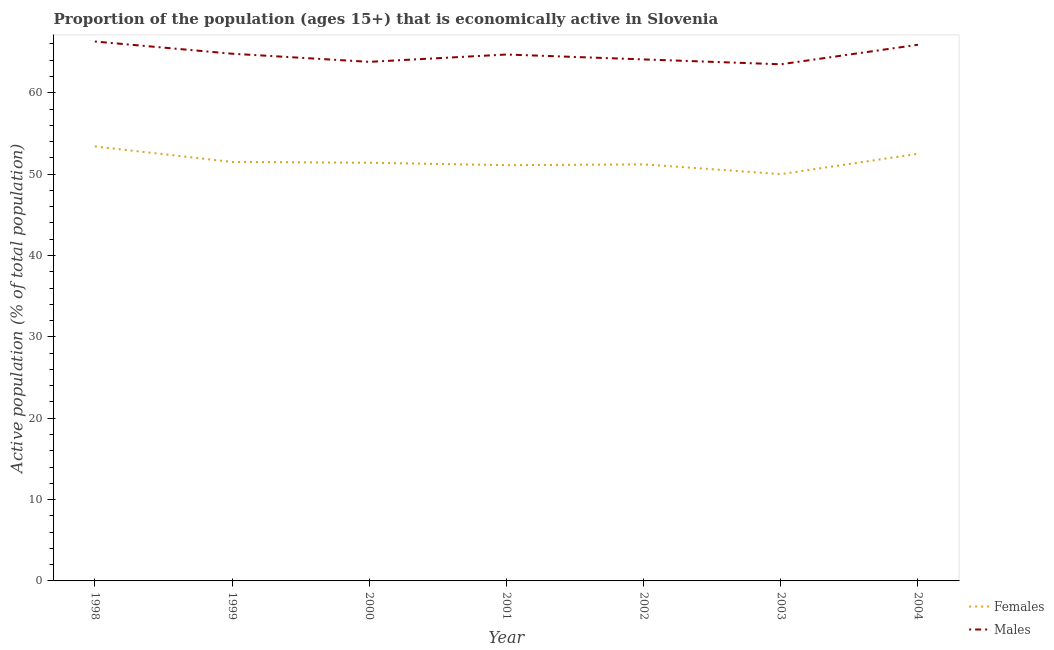What is the percentage of economically active female population in 2002?
Give a very brief answer. 51.2. Across all years, what is the maximum percentage of economically active male population?
Make the answer very short. 66.3. Across all years, what is the minimum percentage of economically active male population?
Offer a very short reply. 63.5. In which year was the percentage of economically active male population maximum?
Your response must be concise. 1998. What is the total percentage of economically active male population in the graph?
Keep it short and to the point. 453.1. What is the difference between the percentage of economically active male population in 2002 and that in 2003?
Make the answer very short. 0.6. What is the difference between the percentage of economically active female population in 2004 and the percentage of economically active male population in 2003?
Make the answer very short. -11. What is the average percentage of economically active female population per year?
Your response must be concise. 51.59. In the year 2002, what is the difference between the percentage of economically active female population and percentage of economically active male population?
Offer a very short reply. -12.9. What is the ratio of the percentage of economically active female population in 1999 to that in 2004?
Provide a succinct answer. 0.98. What is the difference between the highest and the second highest percentage of economically active male population?
Make the answer very short. 0.4. What is the difference between the highest and the lowest percentage of economically active female population?
Provide a short and direct response. 3.4. In how many years, is the percentage of economically active female population greater than the average percentage of economically active female population taken over all years?
Offer a terse response. 2. Does the percentage of economically active male population monotonically increase over the years?
Your response must be concise. No. Is the percentage of economically active male population strictly greater than the percentage of economically active female population over the years?
Make the answer very short. Yes. How many lines are there?
Offer a very short reply. 2. How many years are there in the graph?
Your response must be concise. 7. What is the difference between two consecutive major ticks on the Y-axis?
Give a very brief answer. 10. Are the values on the major ticks of Y-axis written in scientific E-notation?
Your answer should be very brief. No. Where does the legend appear in the graph?
Make the answer very short. Bottom right. What is the title of the graph?
Make the answer very short. Proportion of the population (ages 15+) that is economically active in Slovenia. Does "Urban Population" appear as one of the legend labels in the graph?
Offer a very short reply. No. What is the label or title of the Y-axis?
Make the answer very short. Active population (% of total population). What is the Active population (% of total population) in Females in 1998?
Provide a succinct answer. 53.4. What is the Active population (% of total population) of Males in 1998?
Give a very brief answer. 66.3. What is the Active population (% of total population) in Females in 1999?
Your answer should be compact. 51.5. What is the Active population (% of total population) of Males in 1999?
Ensure brevity in your answer.  64.8. What is the Active population (% of total population) of Females in 2000?
Provide a succinct answer. 51.4. What is the Active population (% of total population) in Males in 2000?
Provide a short and direct response. 63.8. What is the Active population (% of total population) of Females in 2001?
Your response must be concise. 51.1. What is the Active population (% of total population) in Males in 2001?
Keep it short and to the point. 64.7. What is the Active population (% of total population) of Females in 2002?
Your answer should be very brief. 51.2. What is the Active population (% of total population) of Males in 2002?
Make the answer very short. 64.1. What is the Active population (% of total population) of Females in 2003?
Provide a short and direct response. 50. What is the Active population (% of total population) of Males in 2003?
Provide a succinct answer. 63.5. What is the Active population (% of total population) of Females in 2004?
Provide a short and direct response. 52.5. What is the Active population (% of total population) in Males in 2004?
Provide a short and direct response. 65.9. Across all years, what is the maximum Active population (% of total population) in Females?
Provide a succinct answer. 53.4. Across all years, what is the maximum Active population (% of total population) in Males?
Your answer should be very brief. 66.3. Across all years, what is the minimum Active population (% of total population) of Females?
Make the answer very short. 50. Across all years, what is the minimum Active population (% of total population) of Males?
Provide a succinct answer. 63.5. What is the total Active population (% of total population) in Females in the graph?
Keep it short and to the point. 361.1. What is the total Active population (% of total population) in Males in the graph?
Keep it short and to the point. 453.1. What is the difference between the Active population (% of total population) in Males in 1998 and that in 1999?
Ensure brevity in your answer.  1.5. What is the difference between the Active population (% of total population) of Females in 1998 and that in 2000?
Offer a terse response. 2. What is the difference between the Active population (% of total population) of Males in 1998 and that in 2000?
Offer a terse response. 2.5. What is the difference between the Active population (% of total population) of Females in 1998 and that in 2001?
Your answer should be very brief. 2.3. What is the difference between the Active population (% of total population) of Females in 1998 and that in 2002?
Make the answer very short. 2.2. What is the difference between the Active population (% of total population) in Males in 1998 and that in 2002?
Your answer should be very brief. 2.2. What is the difference between the Active population (% of total population) of Females in 1999 and that in 2001?
Offer a very short reply. 0.4. What is the difference between the Active population (% of total population) in Males in 1999 and that in 2004?
Ensure brevity in your answer.  -1.1. What is the difference between the Active population (% of total population) in Males in 2000 and that in 2001?
Ensure brevity in your answer.  -0.9. What is the difference between the Active population (% of total population) of Females in 2000 and that in 2002?
Your answer should be compact. 0.2. What is the difference between the Active population (% of total population) in Males in 2000 and that in 2002?
Ensure brevity in your answer.  -0.3. What is the difference between the Active population (% of total population) of Males in 2000 and that in 2003?
Your response must be concise. 0.3. What is the difference between the Active population (% of total population) in Females in 2000 and that in 2004?
Provide a succinct answer. -1.1. What is the difference between the Active population (% of total population) in Females in 2001 and that in 2003?
Your answer should be very brief. 1.1. What is the difference between the Active population (% of total population) of Males in 2001 and that in 2003?
Provide a short and direct response. 1.2. What is the difference between the Active population (% of total population) of Females in 2001 and that in 2004?
Your answer should be very brief. -1.4. What is the difference between the Active population (% of total population) in Males in 2001 and that in 2004?
Provide a succinct answer. -1.2. What is the difference between the Active population (% of total population) in Females in 2002 and that in 2003?
Offer a very short reply. 1.2. What is the difference between the Active population (% of total population) of Males in 2002 and that in 2004?
Provide a short and direct response. -1.8. What is the difference between the Active population (% of total population) in Females in 2003 and that in 2004?
Give a very brief answer. -2.5. What is the difference between the Active population (% of total population) of Males in 2003 and that in 2004?
Your response must be concise. -2.4. What is the difference between the Active population (% of total population) of Females in 1998 and the Active population (% of total population) of Males in 1999?
Ensure brevity in your answer.  -11.4. What is the difference between the Active population (% of total population) in Females in 1998 and the Active population (% of total population) in Males in 2000?
Ensure brevity in your answer.  -10.4. What is the difference between the Active population (% of total population) in Females in 1998 and the Active population (% of total population) in Males in 2001?
Keep it short and to the point. -11.3. What is the difference between the Active population (% of total population) in Females in 1998 and the Active population (% of total population) in Males in 2002?
Offer a terse response. -10.7. What is the difference between the Active population (% of total population) of Females in 1998 and the Active population (% of total population) of Males in 2004?
Your response must be concise. -12.5. What is the difference between the Active population (% of total population) in Females in 1999 and the Active population (% of total population) in Males in 2000?
Offer a very short reply. -12.3. What is the difference between the Active population (% of total population) of Females in 1999 and the Active population (% of total population) of Males in 2001?
Make the answer very short. -13.2. What is the difference between the Active population (% of total population) in Females in 1999 and the Active population (% of total population) in Males in 2003?
Your answer should be very brief. -12. What is the difference between the Active population (% of total population) in Females in 1999 and the Active population (% of total population) in Males in 2004?
Your answer should be very brief. -14.4. What is the difference between the Active population (% of total population) of Females in 2000 and the Active population (% of total population) of Males in 2001?
Give a very brief answer. -13.3. What is the difference between the Active population (% of total population) of Females in 2000 and the Active population (% of total population) of Males in 2004?
Keep it short and to the point. -14.5. What is the difference between the Active population (% of total population) in Females in 2001 and the Active population (% of total population) in Males in 2002?
Offer a terse response. -13. What is the difference between the Active population (% of total population) of Females in 2001 and the Active population (% of total population) of Males in 2003?
Provide a short and direct response. -12.4. What is the difference between the Active population (% of total population) in Females in 2001 and the Active population (% of total population) in Males in 2004?
Keep it short and to the point. -14.8. What is the difference between the Active population (% of total population) of Females in 2002 and the Active population (% of total population) of Males in 2004?
Provide a succinct answer. -14.7. What is the difference between the Active population (% of total population) of Females in 2003 and the Active population (% of total population) of Males in 2004?
Provide a short and direct response. -15.9. What is the average Active population (% of total population) of Females per year?
Your answer should be very brief. 51.59. What is the average Active population (% of total population) of Males per year?
Make the answer very short. 64.73. In the year 1998, what is the difference between the Active population (% of total population) in Females and Active population (% of total population) in Males?
Make the answer very short. -12.9. In the year 2000, what is the difference between the Active population (% of total population) of Females and Active population (% of total population) of Males?
Make the answer very short. -12.4. In the year 2001, what is the difference between the Active population (% of total population) of Females and Active population (% of total population) of Males?
Offer a terse response. -13.6. In the year 2002, what is the difference between the Active population (% of total population) of Females and Active population (% of total population) of Males?
Your answer should be very brief. -12.9. In the year 2003, what is the difference between the Active population (% of total population) of Females and Active population (% of total population) of Males?
Provide a short and direct response. -13.5. In the year 2004, what is the difference between the Active population (% of total population) in Females and Active population (% of total population) in Males?
Your answer should be very brief. -13.4. What is the ratio of the Active population (% of total population) in Females in 1998 to that in 1999?
Offer a terse response. 1.04. What is the ratio of the Active population (% of total population) in Males in 1998 to that in 1999?
Offer a terse response. 1.02. What is the ratio of the Active population (% of total population) in Females in 1998 to that in 2000?
Offer a terse response. 1.04. What is the ratio of the Active population (% of total population) in Males in 1998 to that in 2000?
Provide a short and direct response. 1.04. What is the ratio of the Active population (% of total population) of Females in 1998 to that in 2001?
Offer a very short reply. 1.04. What is the ratio of the Active population (% of total population) in Males in 1998 to that in 2001?
Your answer should be very brief. 1.02. What is the ratio of the Active population (% of total population) in Females in 1998 to that in 2002?
Make the answer very short. 1.04. What is the ratio of the Active population (% of total population) in Males in 1998 to that in 2002?
Your answer should be compact. 1.03. What is the ratio of the Active population (% of total population) of Females in 1998 to that in 2003?
Your answer should be very brief. 1.07. What is the ratio of the Active population (% of total population) in Males in 1998 to that in 2003?
Offer a very short reply. 1.04. What is the ratio of the Active population (% of total population) in Females in 1998 to that in 2004?
Your response must be concise. 1.02. What is the ratio of the Active population (% of total population) of Males in 1999 to that in 2000?
Keep it short and to the point. 1.02. What is the ratio of the Active population (% of total population) in Females in 1999 to that in 2001?
Ensure brevity in your answer.  1.01. What is the ratio of the Active population (% of total population) of Females in 1999 to that in 2002?
Provide a short and direct response. 1.01. What is the ratio of the Active population (% of total population) in Males in 1999 to that in 2002?
Offer a terse response. 1.01. What is the ratio of the Active population (% of total population) of Females in 1999 to that in 2003?
Provide a succinct answer. 1.03. What is the ratio of the Active population (% of total population) in Males in 1999 to that in 2003?
Make the answer very short. 1.02. What is the ratio of the Active population (% of total population) of Males in 1999 to that in 2004?
Ensure brevity in your answer.  0.98. What is the ratio of the Active population (% of total population) in Females in 2000 to that in 2001?
Keep it short and to the point. 1.01. What is the ratio of the Active population (% of total population) of Males in 2000 to that in 2001?
Keep it short and to the point. 0.99. What is the ratio of the Active population (% of total population) of Females in 2000 to that in 2003?
Your answer should be very brief. 1.03. What is the ratio of the Active population (% of total population) of Males in 2000 to that in 2004?
Give a very brief answer. 0.97. What is the ratio of the Active population (% of total population) of Females in 2001 to that in 2002?
Give a very brief answer. 1. What is the ratio of the Active population (% of total population) of Males in 2001 to that in 2002?
Offer a terse response. 1.01. What is the ratio of the Active population (% of total population) in Females in 2001 to that in 2003?
Your answer should be very brief. 1.02. What is the ratio of the Active population (% of total population) of Males in 2001 to that in 2003?
Keep it short and to the point. 1.02. What is the ratio of the Active population (% of total population) in Females in 2001 to that in 2004?
Give a very brief answer. 0.97. What is the ratio of the Active population (% of total population) in Males in 2001 to that in 2004?
Ensure brevity in your answer.  0.98. What is the ratio of the Active population (% of total population) of Males in 2002 to that in 2003?
Give a very brief answer. 1.01. What is the ratio of the Active population (% of total population) of Females in 2002 to that in 2004?
Provide a succinct answer. 0.98. What is the ratio of the Active population (% of total population) in Males in 2002 to that in 2004?
Offer a very short reply. 0.97. What is the ratio of the Active population (% of total population) of Females in 2003 to that in 2004?
Provide a succinct answer. 0.95. What is the ratio of the Active population (% of total population) in Males in 2003 to that in 2004?
Offer a terse response. 0.96. What is the difference between the highest and the lowest Active population (% of total population) of Females?
Ensure brevity in your answer.  3.4. What is the difference between the highest and the lowest Active population (% of total population) of Males?
Keep it short and to the point. 2.8. 